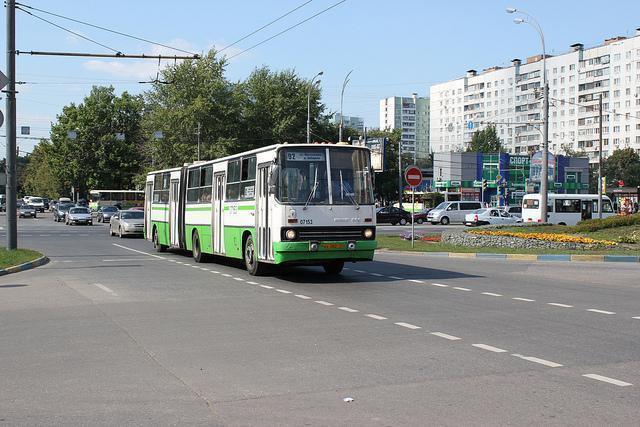What type setting is this roadway located in?
Make your selection and explain in format: 'Answer: answer
Rationale: rationale.'
Options: Rural, north pole, urban, tundra. Answer: urban.
Rationale: The setting is urban. 